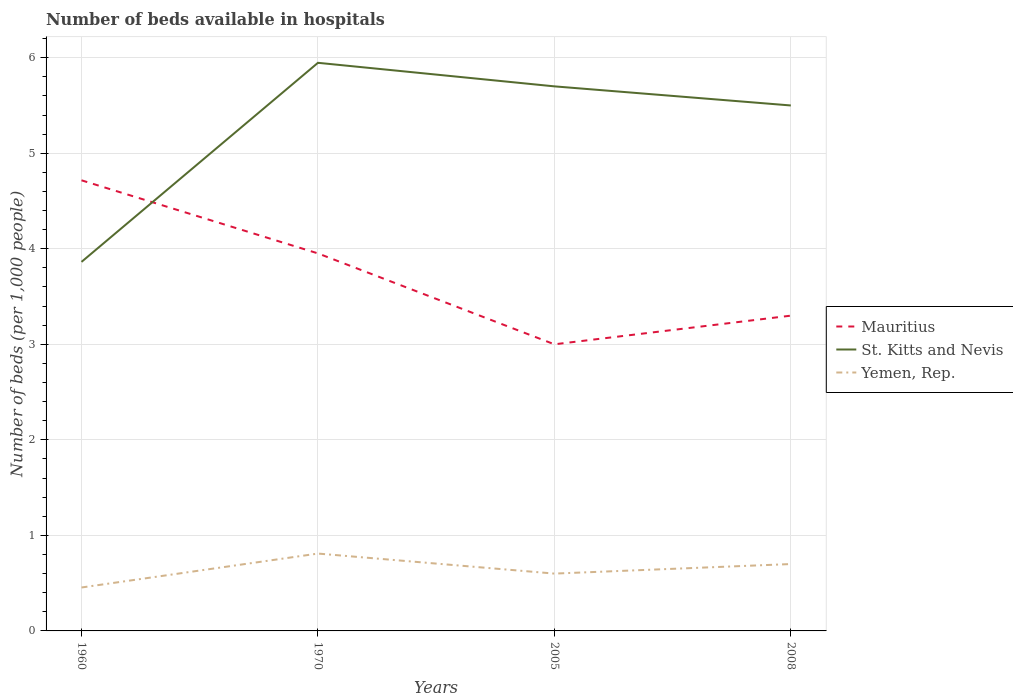How many different coloured lines are there?
Keep it short and to the point. 3. Is the number of lines equal to the number of legend labels?
Offer a very short reply. Yes. In which year was the number of beds in the hospiatls of in Yemen, Rep. maximum?
Give a very brief answer. 1960. What is the total number of beds in the hospiatls of in St. Kitts and Nevis in the graph?
Provide a succinct answer. 0.45. What is the difference between the highest and the second highest number of beds in the hospiatls of in Mauritius?
Offer a terse response. 1.72. What is the difference between the highest and the lowest number of beds in the hospiatls of in Yemen, Rep.?
Provide a short and direct response. 2. Is the number of beds in the hospiatls of in Yemen, Rep. strictly greater than the number of beds in the hospiatls of in Mauritius over the years?
Offer a terse response. Yes. What is the difference between two consecutive major ticks on the Y-axis?
Provide a succinct answer. 1. Are the values on the major ticks of Y-axis written in scientific E-notation?
Ensure brevity in your answer.  No. Does the graph contain any zero values?
Ensure brevity in your answer.  No. What is the title of the graph?
Keep it short and to the point. Number of beds available in hospitals. Does "Latin America(developing only)" appear as one of the legend labels in the graph?
Give a very brief answer. No. What is the label or title of the Y-axis?
Make the answer very short. Number of beds (per 1,0 people). What is the Number of beds (per 1,000 people) in Mauritius in 1960?
Your response must be concise. 4.72. What is the Number of beds (per 1,000 people) of St. Kitts and Nevis in 1960?
Make the answer very short. 3.86. What is the Number of beds (per 1,000 people) in Yemen, Rep. in 1960?
Offer a terse response. 0.45. What is the Number of beds (per 1,000 people) of Mauritius in 1970?
Provide a short and direct response. 3.95. What is the Number of beds (per 1,000 people) in St. Kitts and Nevis in 1970?
Your answer should be very brief. 5.95. What is the Number of beds (per 1,000 people) in Yemen, Rep. in 1970?
Your answer should be very brief. 0.81. What is the Number of beds (per 1,000 people) in Mauritius in 2005?
Ensure brevity in your answer.  3. What is the Number of beds (per 1,000 people) in St. Kitts and Nevis in 2005?
Your answer should be compact. 5.7. What is the Number of beds (per 1,000 people) of St. Kitts and Nevis in 2008?
Your answer should be very brief. 5.5. What is the Number of beds (per 1,000 people) in Yemen, Rep. in 2008?
Provide a short and direct response. 0.7. Across all years, what is the maximum Number of beds (per 1,000 people) of Mauritius?
Your answer should be very brief. 4.72. Across all years, what is the maximum Number of beds (per 1,000 people) of St. Kitts and Nevis?
Your response must be concise. 5.95. Across all years, what is the maximum Number of beds (per 1,000 people) of Yemen, Rep.?
Give a very brief answer. 0.81. Across all years, what is the minimum Number of beds (per 1,000 people) in Mauritius?
Give a very brief answer. 3. Across all years, what is the minimum Number of beds (per 1,000 people) of St. Kitts and Nevis?
Ensure brevity in your answer.  3.86. Across all years, what is the minimum Number of beds (per 1,000 people) of Yemen, Rep.?
Make the answer very short. 0.45. What is the total Number of beds (per 1,000 people) in Mauritius in the graph?
Your answer should be very brief. 14.97. What is the total Number of beds (per 1,000 people) of St. Kitts and Nevis in the graph?
Offer a very short reply. 21.01. What is the total Number of beds (per 1,000 people) in Yemen, Rep. in the graph?
Make the answer very short. 2.56. What is the difference between the Number of beds (per 1,000 people) in Mauritius in 1960 and that in 1970?
Keep it short and to the point. 0.77. What is the difference between the Number of beds (per 1,000 people) of St. Kitts and Nevis in 1960 and that in 1970?
Make the answer very short. -2.08. What is the difference between the Number of beds (per 1,000 people) in Yemen, Rep. in 1960 and that in 1970?
Provide a short and direct response. -0.36. What is the difference between the Number of beds (per 1,000 people) of Mauritius in 1960 and that in 2005?
Give a very brief answer. 1.72. What is the difference between the Number of beds (per 1,000 people) in St. Kitts and Nevis in 1960 and that in 2005?
Offer a terse response. -1.84. What is the difference between the Number of beds (per 1,000 people) of Yemen, Rep. in 1960 and that in 2005?
Your response must be concise. -0.15. What is the difference between the Number of beds (per 1,000 people) in Mauritius in 1960 and that in 2008?
Offer a very short reply. 1.42. What is the difference between the Number of beds (per 1,000 people) in St. Kitts and Nevis in 1960 and that in 2008?
Give a very brief answer. -1.64. What is the difference between the Number of beds (per 1,000 people) of Yemen, Rep. in 1960 and that in 2008?
Provide a short and direct response. -0.25. What is the difference between the Number of beds (per 1,000 people) in Mauritius in 1970 and that in 2005?
Provide a short and direct response. 0.95. What is the difference between the Number of beds (per 1,000 people) in St. Kitts and Nevis in 1970 and that in 2005?
Ensure brevity in your answer.  0.25. What is the difference between the Number of beds (per 1,000 people) of Yemen, Rep. in 1970 and that in 2005?
Offer a terse response. 0.21. What is the difference between the Number of beds (per 1,000 people) in Mauritius in 1970 and that in 2008?
Offer a terse response. 0.65. What is the difference between the Number of beds (per 1,000 people) of St. Kitts and Nevis in 1970 and that in 2008?
Make the answer very short. 0.45. What is the difference between the Number of beds (per 1,000 people) of Yemen, Rep. in 1970 and that in 2008?
Provide a short and direct response. 0.11. What is the difference between the Number of beds (per 1,000 people) in St. Kitts and Nevis in 2005 and that in 2008?
Your answer should be very brief. 0.2. What is the difference between the Number of beds (per 1,000 people) in Yemen, Rep. in 2005 and that in 2008?
Give a very brief answer. -0.1. What is the difference between the Number of beds (per 1,000 people) in Mauritius in 1960 and the Number of beds (per 1,000 people) in St. Kitts and Nevis in 1970?
Give a very brief answer. -1.23. What is the difference between the Number of beds (per 1,000 people) in Mauritius in 1960 and the Number of beds (per 1,000 people) in Yemen, Rep. in 1970?
Your response must be concise. 3.91. What is the difference between the Number of beds (per 1,000 people) of St. Kitts and Nevis in 1960 and the Number of beds (per 1,000 people) of Yemen, Rep. in 1970?
Your answer should be very brief. 3.05. What is the difference between the Number of beds (per 1,000 people) in Mauritius in 1960 and the Number of beds (per 1,000 people) in St. Kitts and Nevis in 2005?
Make the answer very short. -0.98. What is the difference between the Number of beds (per 1,000 people) of Mauritius in 1960 and the Number of beds (per 1,000 people) of Yemen, Rep. in 2005?
Offer a very short reply. 4.12. What is the difference between the Number of beds (per 1,000 people) in St. Kitts and Nevis in 1960 and the Number of beds (per 1,000 people) in Yemen, Rep. in 2005?
Your answer should be very brief. 3.26. What is the difference between the Number of beds (per 1,000 people) in Mauritius in 1960 and the Number of beds (per 1,000 people) in St. Kitts and Nevis in 2008?
Make the answer very short. -0.78. What is the difference between the Number of beds (per 1,000 people) of Mauritius in 1960 and the Number of beds (per 1,000 people) of Yemen, Rep. in 2008?
Offer a terse response. 4.02. What is the difference between the Number of beds (per 1,000 people) in St. Kitts and Nevis in 1960 and the Number of beds (per 1,000 people) in Yemen, Rep. in 2008?
Provide a short and direct response. 3.16. What is the difference between the Number of beds (per 1,000 people) in Mauritius in 1970 and the Number of beds (per 1,000 people) in St. Kitts and Nevis in 2005?
Give a very brief answer. -1.75. What is the difference between the Number of beds (per 1,000 people) of Mauritius in 1970 and the Number of beds (per 1,000 people) of Yemen, Rep. in 2005?
Give a very brief answer. 3.35. What is the difference between the Number of beds (per 1,000 people) of St. Kitts and Nevis in 1970 and the Number of beds (per 1,000 people) of Yemen, Rep. in 2005?
Keep it short and to the point. 5.35. What is the difference between the Number of beds (per 1,000 people) of Mauritius in 1970 and the Number of beds (per 1,000 people) of St. Kitts and Nevis in 2008?
Keep it short and to the point. -1.55. What is the difference between the Number of beds (per 1,000 people) of Mauritius in 1970 and the Number of beds (per 1,000 people) of Yemen, Rep. in 2008?
Your answer should be compact. 3.25. What is the difference between the Number of beds (per 1,000 people) in St. Kitts and Nevis in 1970 and the Number of beds (per 1,000 people) in Yemen, Rep. in 2008?
Your answer should be very brief. 5.25. What is the difference between the Number of beds (per 1,000 people) in St. Kitts and Nevis in 2005 and the Number of beds (per 1,000 people) in Yemen, Rep. in 2008?
Keep it short and to the point. 5. What is the average Number of beds (per 1,000 people) of Mauritius per year?
Your answer should be compact. 3.74. What is the average Number of beds (per 1,000 people) of St. Kitts and Nevis per year?
Offer a terse response. 5.25. What is the average Number of beds (per 1,000 people) of Yemen, Rep. per year?
Offer a very short reply. 0.64. In the year 1960, what is the difference between the Number of beds (per 1,000 people) in Mauritius and Number of beds (per 1,000 people) in St. Kitts and Nevis?
Your answer should be very brief. 0.85. In the year 1960, what is the difference between the Number of beds (per 1,000 people) of Mauritius and Number of beds (per 1,000 people) of Yemen, Rep.?
Keep it short and to the point. 4.26. In the year 1960, what is the difference between the Number of beds (per 1,000 people) in St. Kitts and Nevis and Number of beds (per 1,000 people) in Yemen, Rep.?
Keep it short and to the point. 3.41. In the year 1970, what is the difference between the Number of beds (per 1,000 people) in Mauritius and Number of beds (per 1,000 people) in St. Kitts and Nevis?
Give a very brief answer. -1.99. In the year 1970, what is the difference between the Number of beds (per 1,000 people) in Mauritius and Number of beds (per 1,000 people) in Yemen, Rep.?
Give a very brief answer. 3.14. In the year 1970, what is the difference between the Number of beds (per 1,000 people) of St. Kitts and Nevis and Number of beds (per 1,000 people) of Yemen, Rep.?
Your answer should be very brief. 5.14. In the year 2005, what is the difference between the Number of beds (per 1,000 people) in Mauritius and Number of beds (per 1,000 people) in St. Kitts and Nevis?
Your answer should be compact. -2.7. In the year 2005, what is the difference between the Number of beds (per 1,000 people) in Mauritius and Number of beds (per 1,000 people) in Yemen, Rep.?
Offer a very short reply. 2.4. In the year 2008, what is the difference between the Number of beds (per 1,000 people) in Mauritius and Number of beds (per 1,000 people) in St. Kitts and Nevis?
Ensure brevity in your answer.  -2.2. In the year 2008, what is the difference between the Number of beds (per 1,000 people) of Mauritius and Number of beds (per 1,000 people) of Yemen, Rep.?
Offer a terse response. 2.6. In the year 2008, what is the difference between the Number of beds (per 1,000 people) of St. Kitts and Nevis and Number of beds (per 1,000 people) of Yemen, Rep.?
Your answer should be very brief. 4.8. What is the ratio of the Number of beds (per 1,000 people) of Mauritius in 1960 to that in 1970?
Provide a short and direct response. 1.19. What is the ratio of the Number of beds (per 1,000 people) in St. Kitts and Nevis in 1960 to that in 1970?
Make the answer very short. 0.65. What is the ratio of the Number of beds (per 1,000 people) in Yemen, Rep. in 1960 to that in 1970?
Give a very brief answer. 0.56. What is the ratio of the Number of beds (per 1,000 people) of Mauritius in 1960 to that in 2005?
Provide a short and direct response. 1.57. What is the ratio of the Number of beds (per 1,000 people) of St. Kitts and Nevis in 1960 to that in 2005?
Your answer should be compact. 0.68. What is the ratio of the Number of beds (per 1,000 people) of Yemen, Rep. in 1960 to that in 2005?
Ensure brevity in your answer.  0.76. What is the ratio of the Number of beds (per 1,000 people) of Mauritius in 1960 to that in 2008?
Your answer should be very brief. 1.43. What is the ratio of the Number of beds (per 1,000 people) in St. Kitts and Nevis in 1960 to that in 2008?
Keep it short and to the point. 0.7. What is the ratio of the Number of beds (per 1,000 people) in Yemen, Rep. in 1960 to that in 2008?
Give a very brief answer. 0.65. What is the ratio of the Number of beds (per 1,000 people) in Mauritius in 1970 to that in 2005?
Ensure brevity in your answer.  1.32. What is the ratio of the Number of beds (per 1,000 people) in St. Kitts and Nevis in 1970 to that in 2005?
Give a very brief answer. 1.04. What is the ratio of the Number of beds (per 1,000 people) of Yemen, Rep. in 1970 to that in 2005?
Provide a short and direct response. 1.35. What is the ratio of the Number of beds (per 1,000 people) of Mauritius in 1970 to that in 2008?
Provide a short and direct response. 1.2. What is the ratio of the Number of beds (per 1,000 people) in St. Kitts and Nevis in 1970 to that in 2008?
Provide a short and direct response. 1.08. What is the ratio of the Number of beds (per 1,000 people) in Yemen, Rep. in 1970 to that in 2008?
Your answer should be very brief. 1.16. What is the ratio of the Number of beds (per 1,000 people) of Mauritius in 2005 to that in 2008?
Ensure brevity in your answer.  0.91. What is the ratio of the Number of beds (per 1,000 people) in St. Kitts and Nevis in 2005 to that in 2008?
Keep it short and to the point. 1.04. What is the ratio of the Number of beds (per 1,000 people) in Yemen, Rep. in 2005 to that in 2008?
Make the answer very short. 0.86. What is the difference between the highest and the second highest Number of beds (per 1,000 people) of Mauritius?
Your answer should be very brief. 0.77. What is the difference between the highest and the second highest Number of beds (per 1,000 people) of St. Kitts and Nevis?
Provide a short and direct response. 0.25. What is the difference between the highest and the second highest Number of beds (per 1,000 people) of Yemen, Rep.?
Give a very brief answer. 0.11. What is the difference between the highest and the lowest Number of beds (per 1,000 people) in Mauritius?
Your answer should be very brief. 1.72. What is the difference between the highest and the lowest Number of beds (per 1,000 people) in St. Kitts and Nevis?
Provide a succinct answer. 2.08. What is the difference between the highest and the lowest Number of beds (per 1,000 people) of Yemen, Rep.?
Make the answer very short. 0.36. 